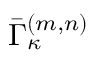<formula> <loc_0><loc_0><loc_500><loc_500>\bar { \Gamma } _ { \kappa } ^ { ( m , n ) }</formula> 